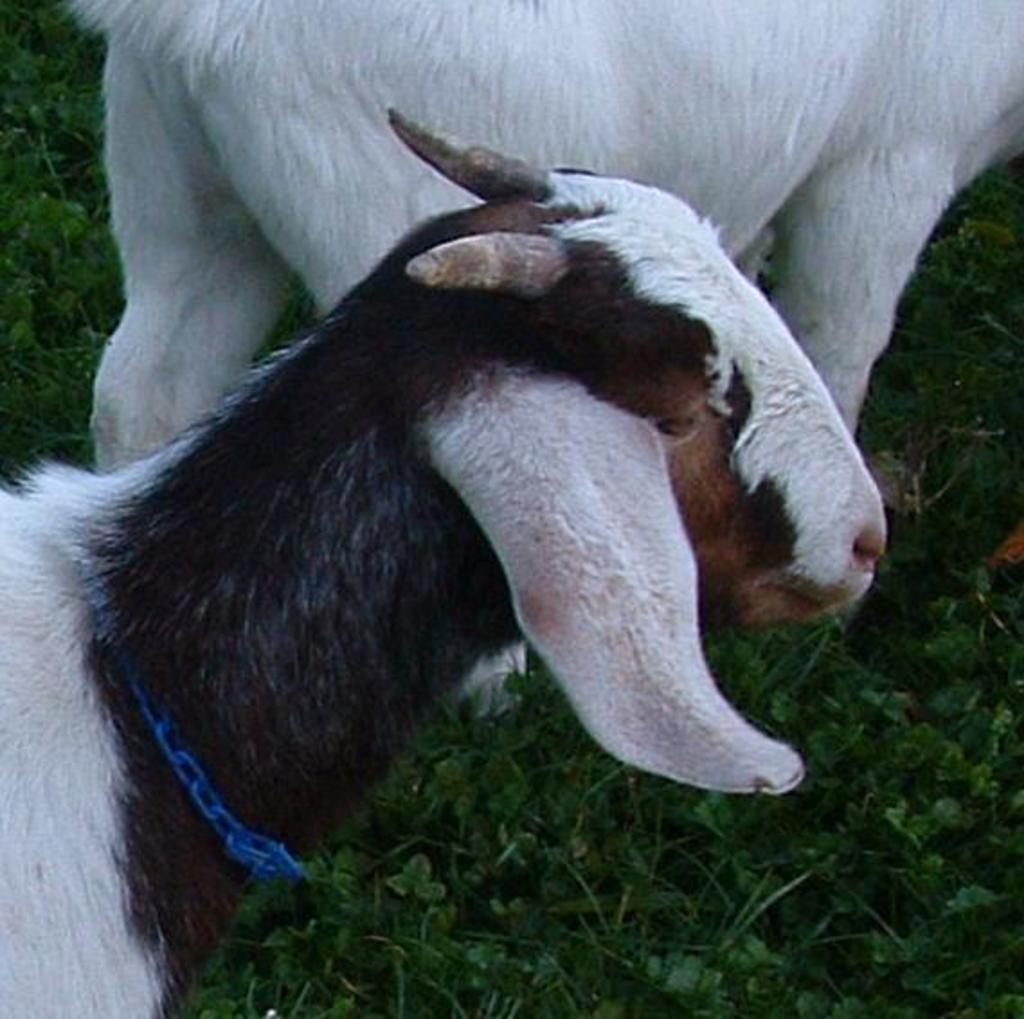Please provide a concise description of this image. In this image there is grass and there are two goats. 